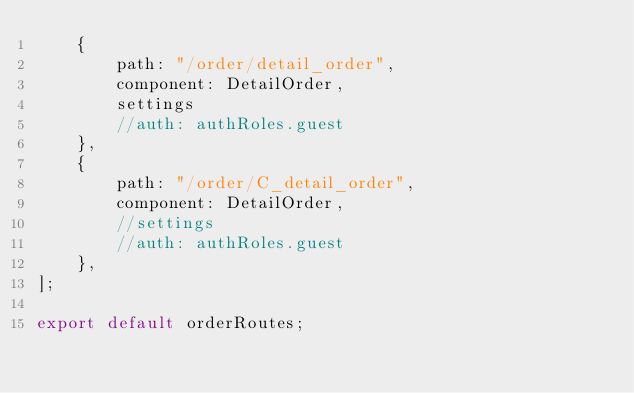Convert code to text. <code><loc_0><loc_0><loc_500><loc_500><_JavaScript_>    {
        path: "/order/detail_order",
        component: DetailOrder,
        settings
        //auth: authRoles.guest
    },
    {
        path: "/order/C_detail_order",
        component: DetailOrder,
        //settings
        //auth: authRoles.guest
    },
];

export default orderRoutes;</code> 